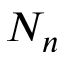Convert formula to latex. <formula><loc_0><loc_0><loc_500><loc_500>N _ { n }</formula> 